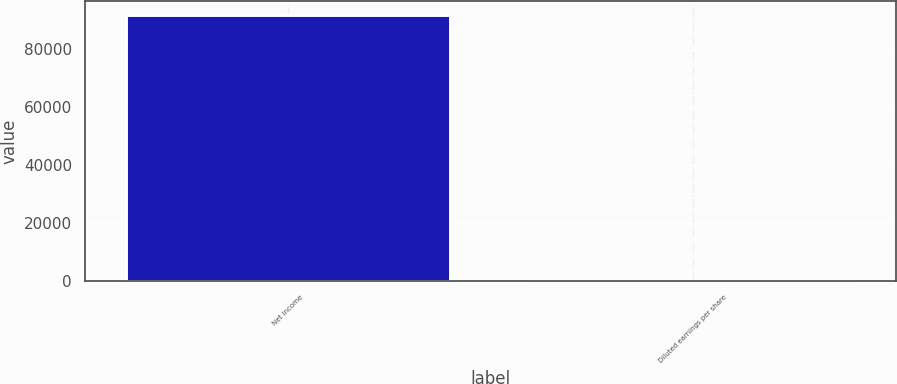<chart> <loc_0><loc_0><loc_500><loc_500><bar_chart><fcel>Net income<fcel>Diluted earnings per share<nl><fcel>91696<fcel>1.28<nl></chart> 